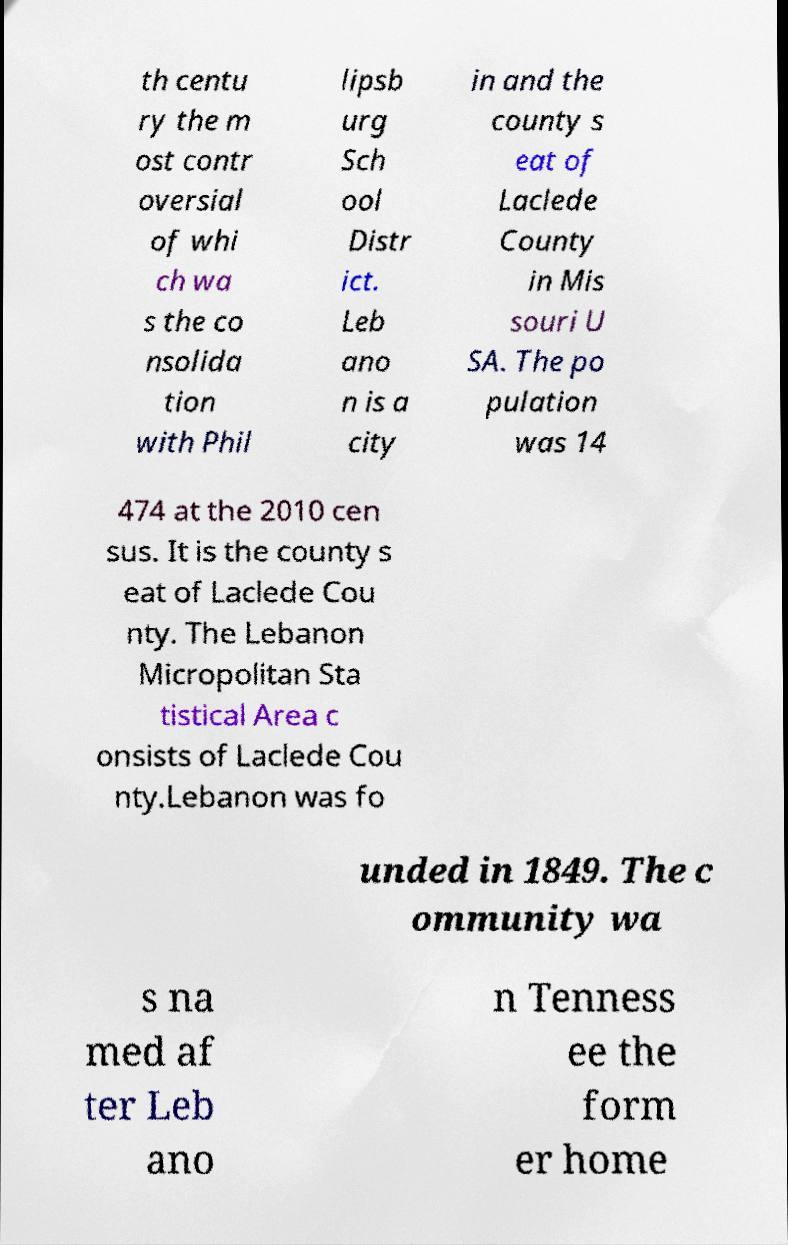Can you read and provide the text displayed in the image?This photo seems to have some interesting text. Can you extract and type it out for me? th centu ry the m ost contr oversial of whi ch wa s the co nsolida tion with Phil lipsb urg Sch ool Distr ict. Leb ano n is a city in and the county s eat of Laclede County in Mis souri U SA. The po pulation was 14 474 at the 2010 cen sus. It is the county s eat of Laclede Cou nty. The Lebanon Micropolitan Sta tistical Area c onsists of Laclede Cou nty.Lebanon was fo unded in 1849. The c ommunity wa s na med af ter Leb ano n Tenness ee the form er home 